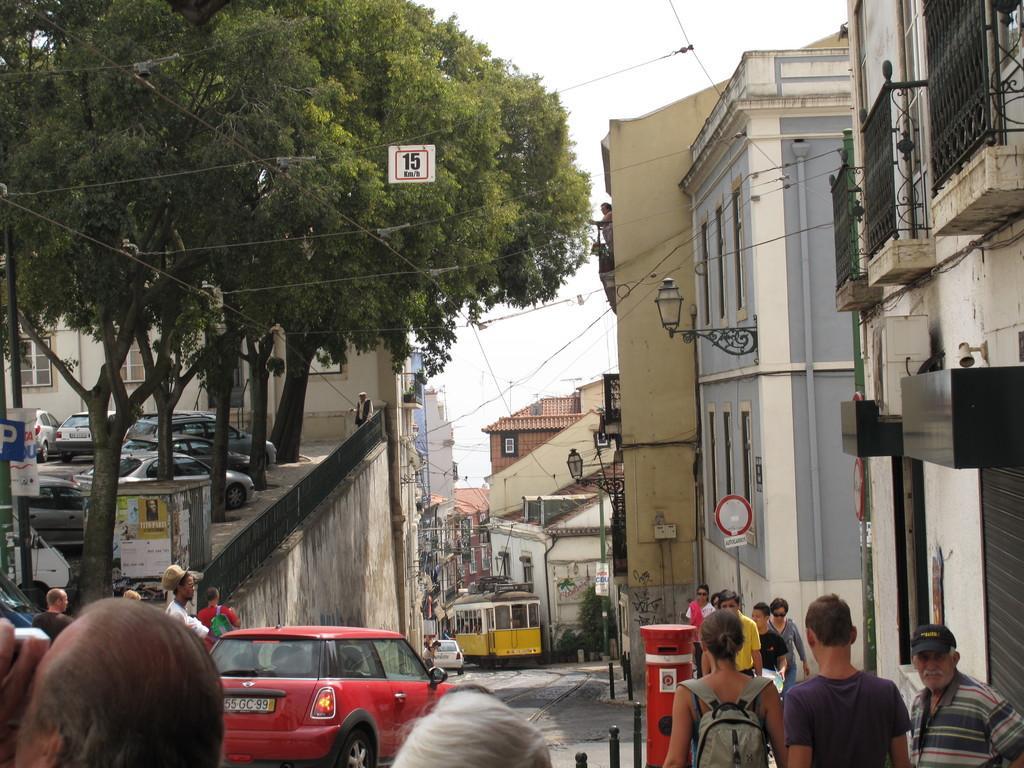How would you summarize this image in a sentence or two? In this picture I can see few people in front and in the middle of this picture I can see number of cars, trees, wires and few more people. In the background I can see the buildings, a tram and the sky. 